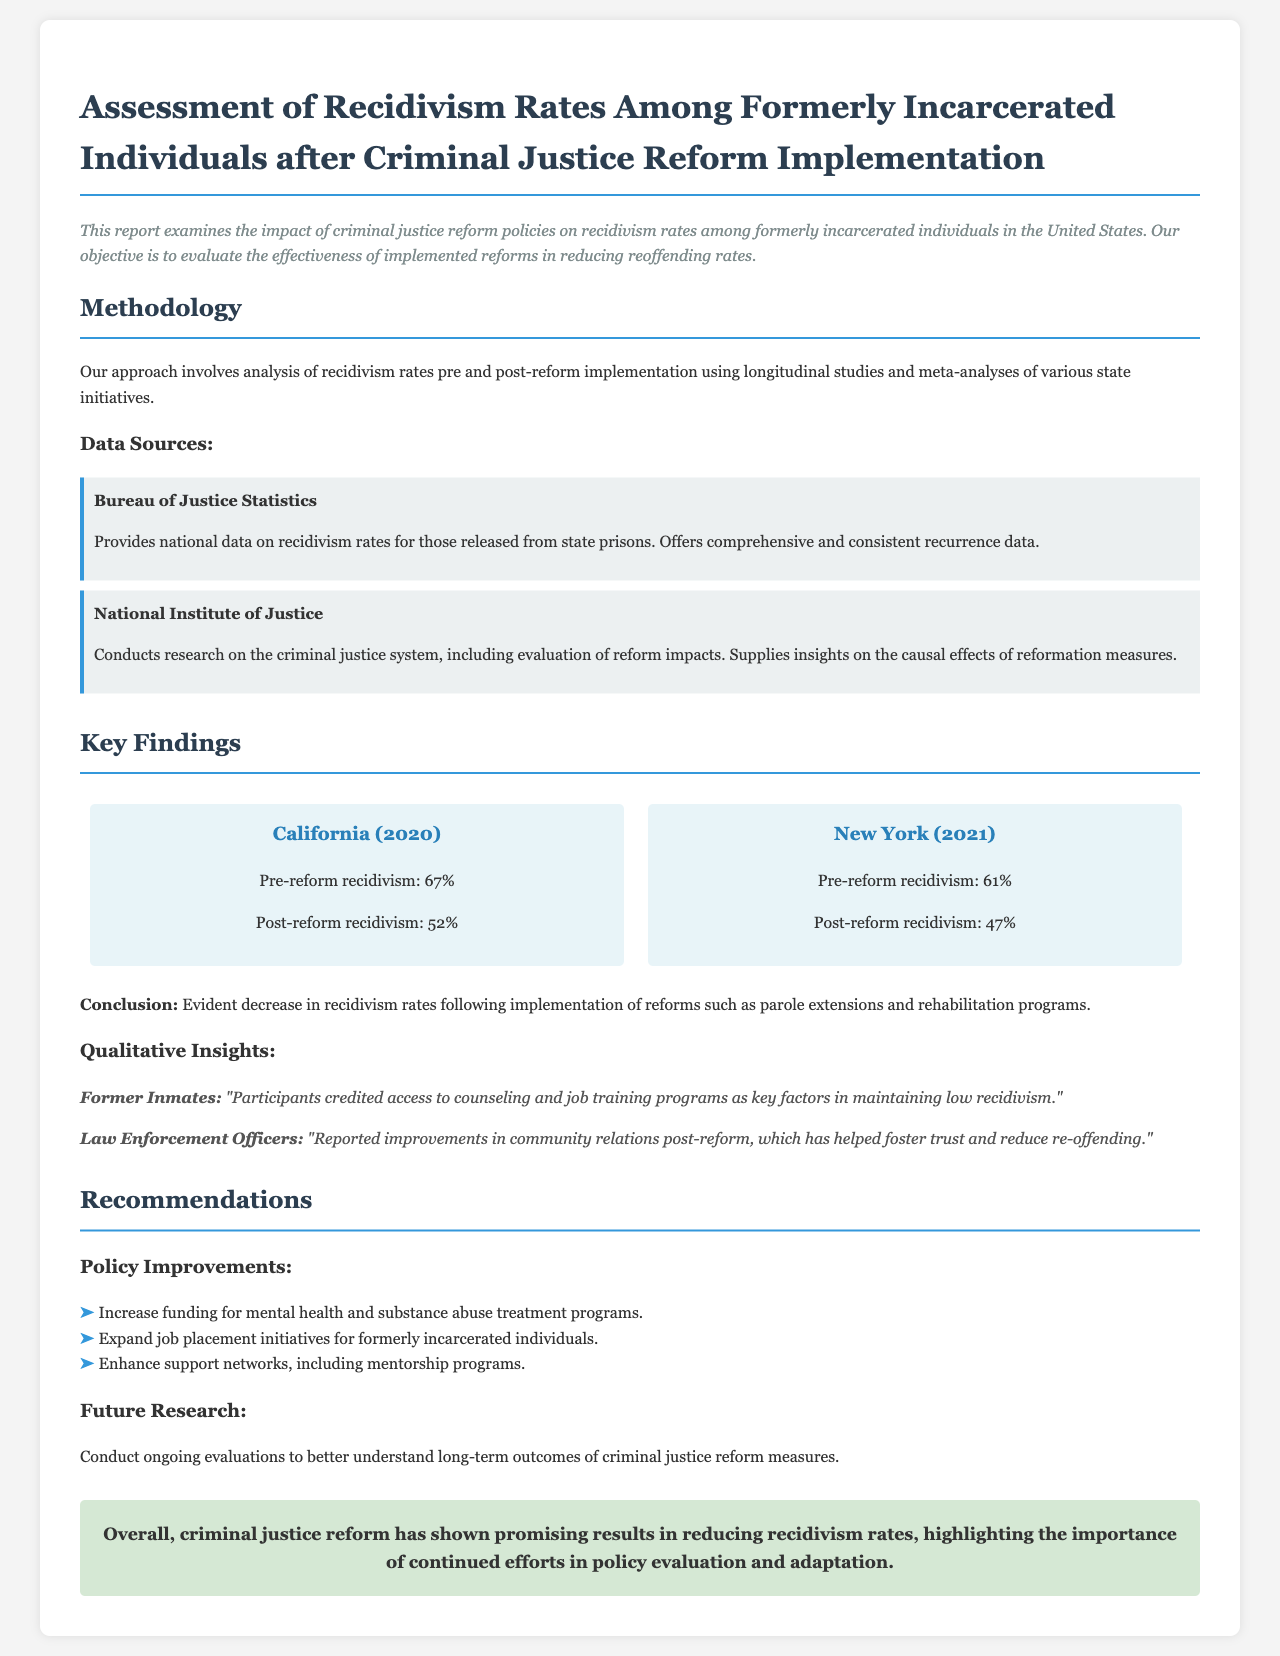What is the main objective of the report? The report aims to evaluate the effectiveness of implemented reforms in reducing reoffending rates among formerly incarcerated individuals.
Answer: To evaluate effectiveness of implemented reforms What was the post-reform recidivism rate in California? The document provides specific pre and post-reform recidivism rates for California, indicating a decrease after reforms were implemented.
Answer: 52% Which organization provided national data on recidivism rates? The report mentions the Bureau of Justice Statistics as a source of national data on recidivism rates for those released from state prisons.
Answer: Bureau of Justice Statistics What qualitative insight did former inmates provide regarding recidivism? The feedback section discusses insights from former inmates, specifically how they attribute their low recidivism to certain programs.
Answer: Access to counseling and job training programs What funding increase is recommended? The recommendations section emphasizes the need for increased funding in specific areas to support the reformation efforts.
Answer: Mental health and substance abuse treatment programs What was the pre-reform recidivism rate in New York? The report provides a specific pre-reform recidivism rate for New York that can be retrieved easily from the findings section.
Answer: 61% What year does the California data refer to? The report specifically mentions the year when the California data was recorded right before the recidivism rates.
Answer: 2020 What is highlighted as a key factor in reducing re-offending? The conclusion summarizes the overall success of criminal justice reform and mentions supportive actions taken to reduce recidivism.
Answer: Importance of continued efforts in policy evaluation and adaptation 